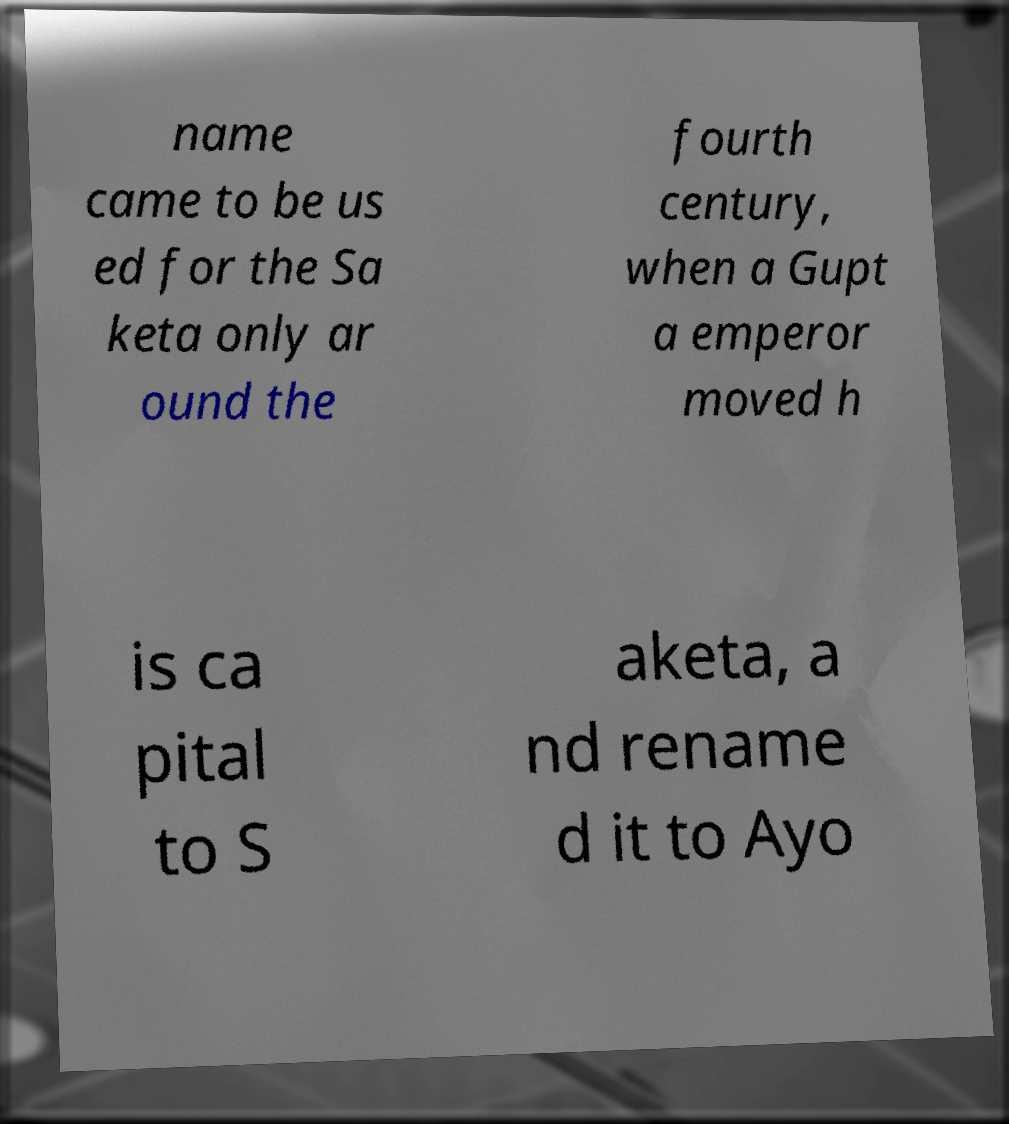What messages or text are displayed in this image? I need them in a readable, typed format. name came to be us ed for the Sa keta only ar ound the fourth century, when a Gupt a emperor moved h is ca pital to S aketa, a nd rename d it to Ayo 